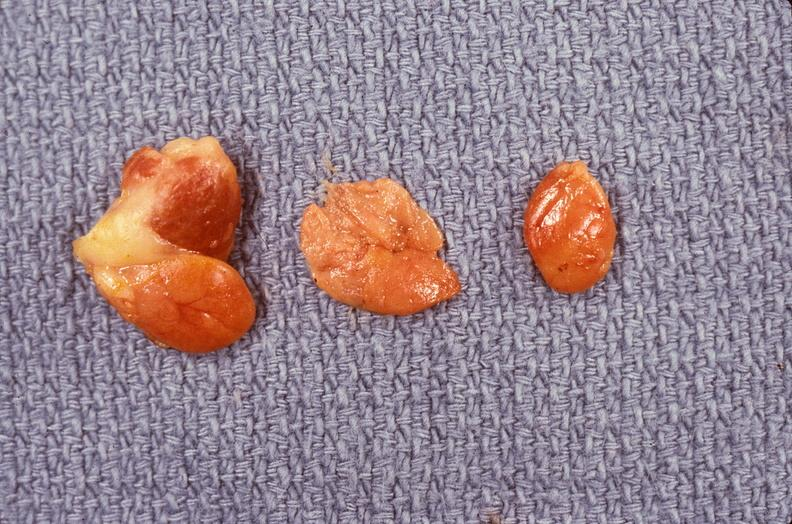what is present?
Answer the question using a single word or phrase. Endocrine 